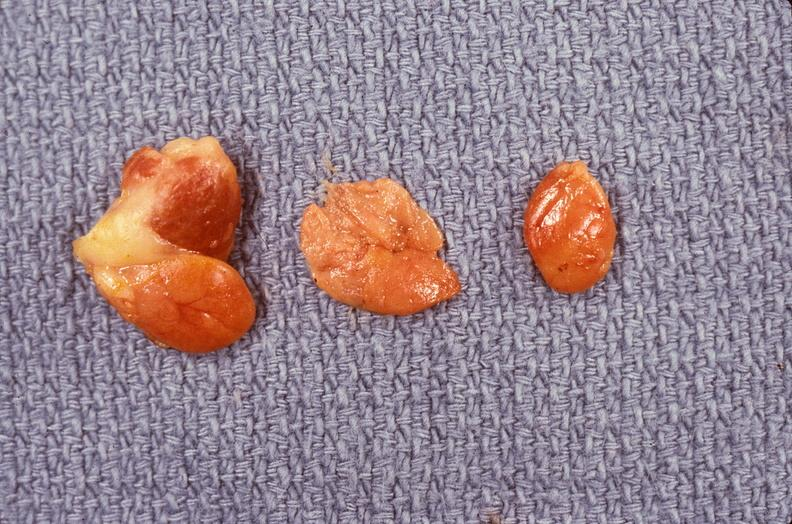what is present?
Answer the question using a single word or phrase. Endocrine 